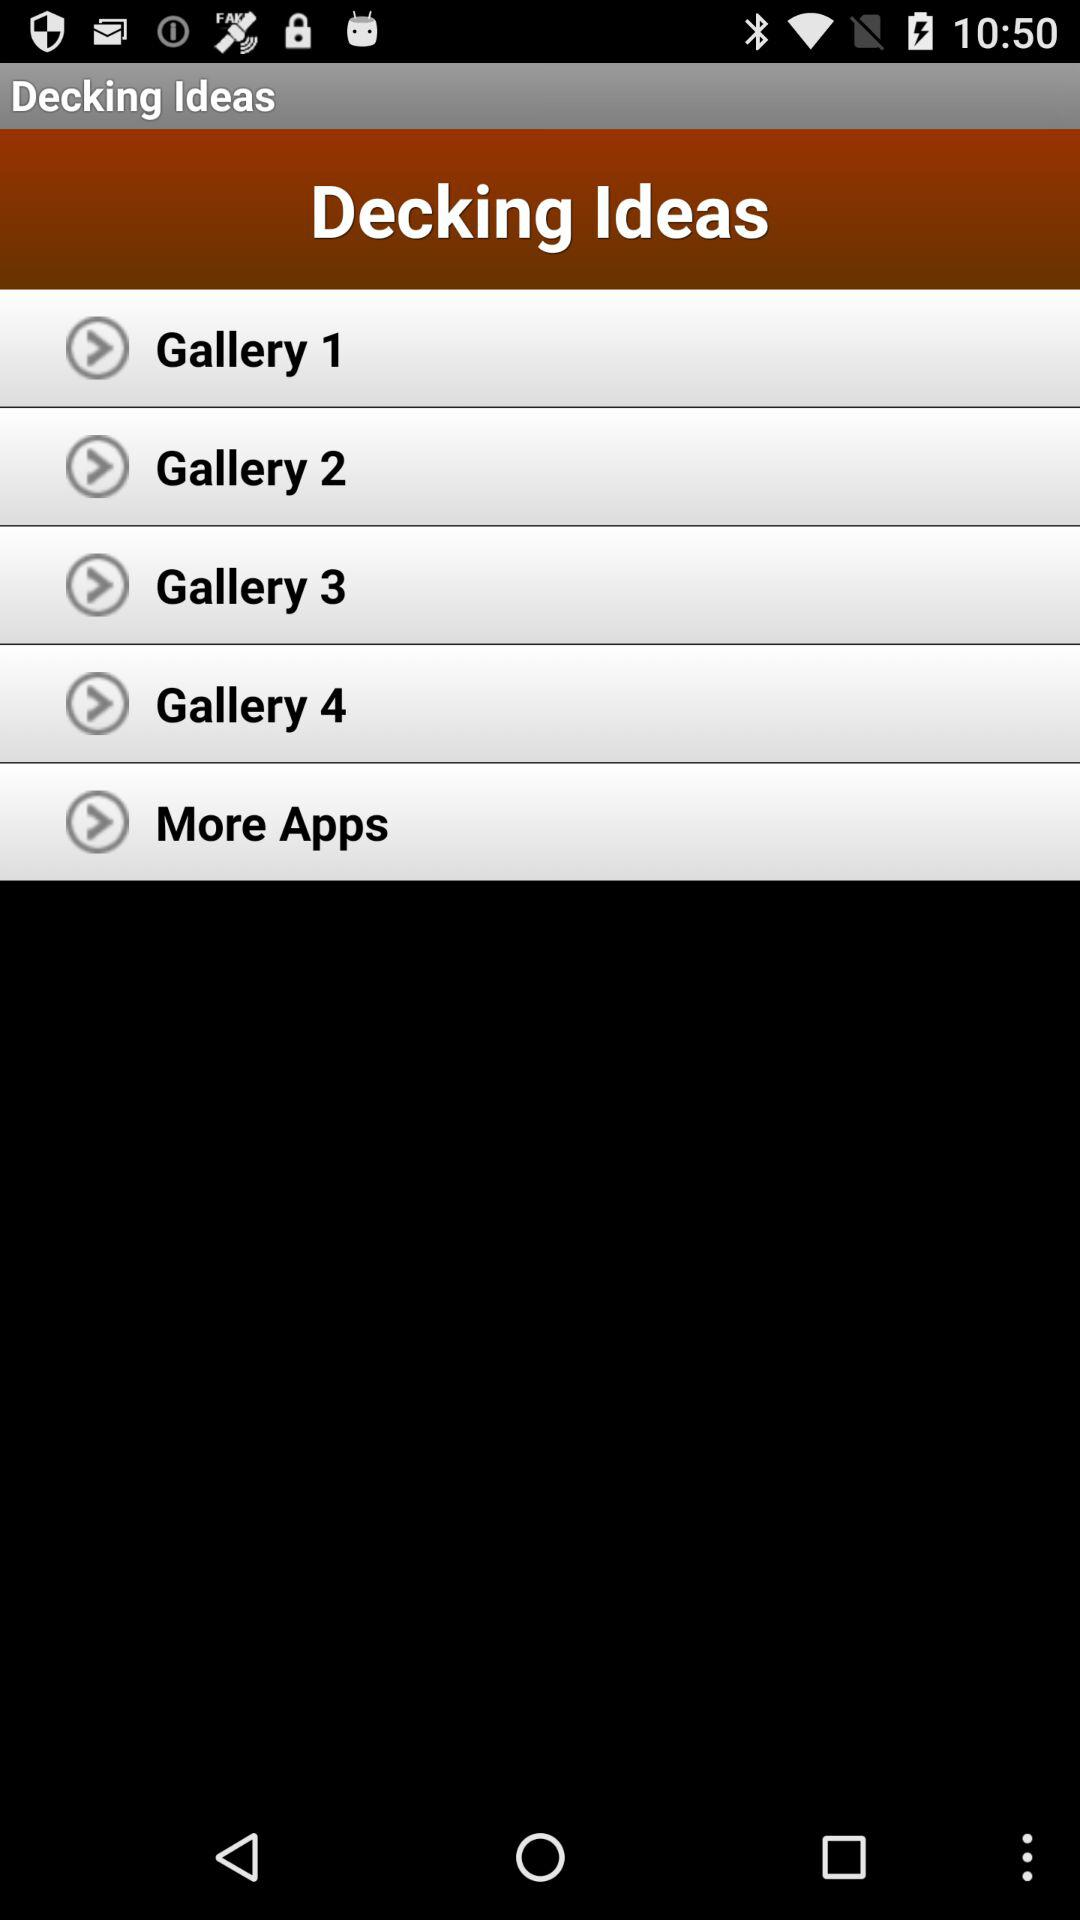How many gallery items are there?
Answer the question using a single word or phrase. 4 